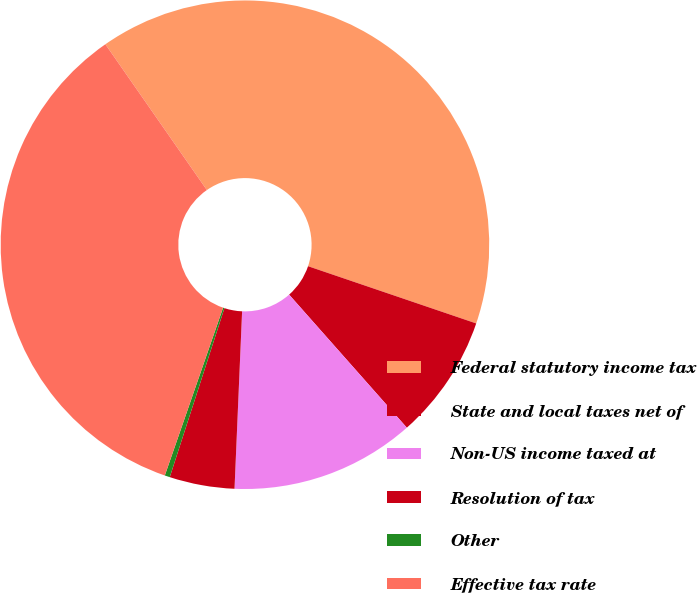Convert chart. <chart><loc_0><loc_0><loc_500><loc_500><pie_chart><fcel>Federal statutory income tax<fcel>State and local taxes net of<fcel>Non-US income taxed at<fcel>Resolution of tax<fcel>Other<fcel>Effective tax rate<nl><fcel>39.9%<fcel>8.25%<fcel>12.21%<fcel>4.3%<fcel>0.34%<fcel>35.0%<nl></chart> 